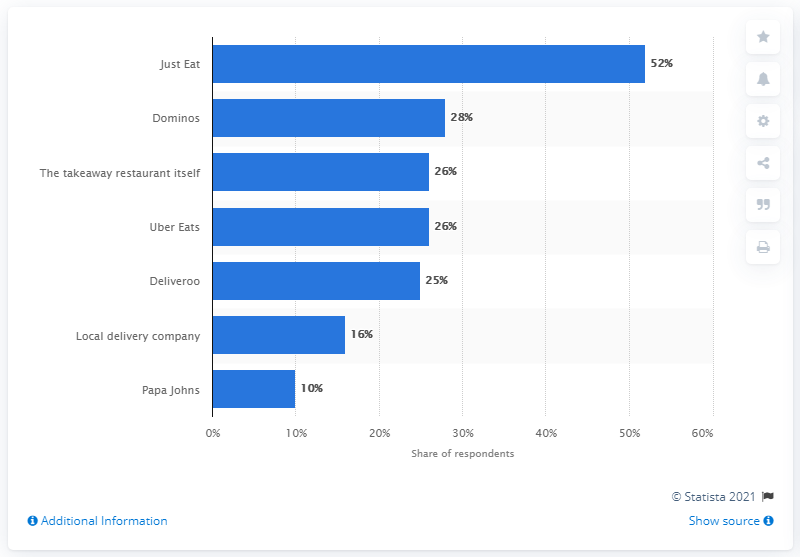Point out several critical features in this image. The most popular takeaway delivery service was Just Eat. 